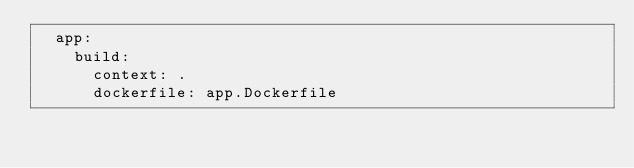Convert code to text. <code><loc_0><loc_0><loc_500><loc_500><_YAML_>  app:
    build:
      context: .
      dockerfile: app.Dockerfile</code> 